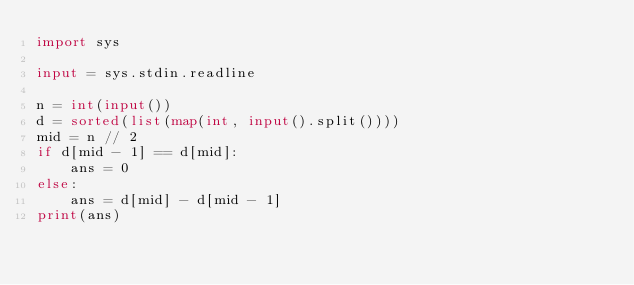<code> <loc_0><loc_0><loc_500><loc_500><_Python_>import sys

input = sys.stdin.readline

n = int(input())
d = sorted(list(map(int, input().split())))
mid = n // 2
if d[mid - 1] == d[mid]:
    ans = 0
else:
    ans = d[mid] - d[mid - 1]
print(ans)
</code> 